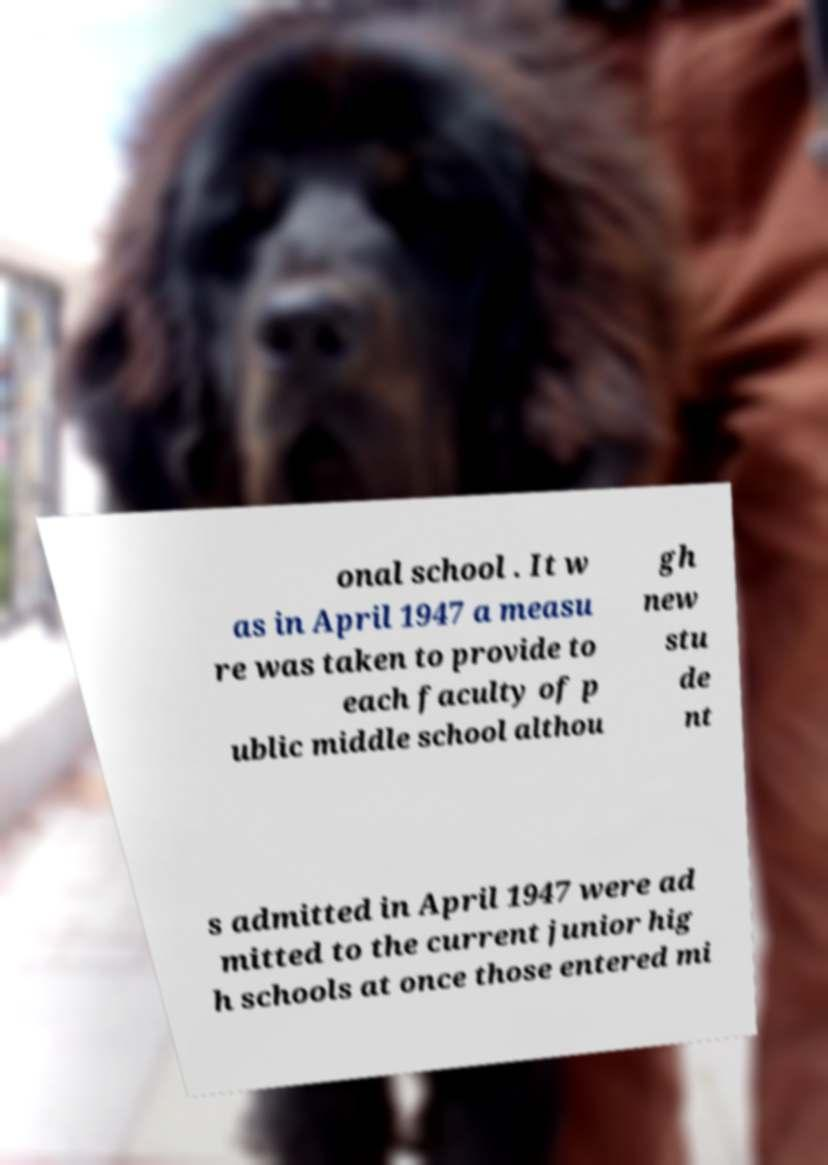Please identify and transcribe the text found in this image. onal school . It w as in April 1947 a measu re was taken to provide to each faculty of p ublic middle school althou gh new stu de nt s admitted in April 1947 were ad mitted to the current junior hig h schools at once those entered mi 